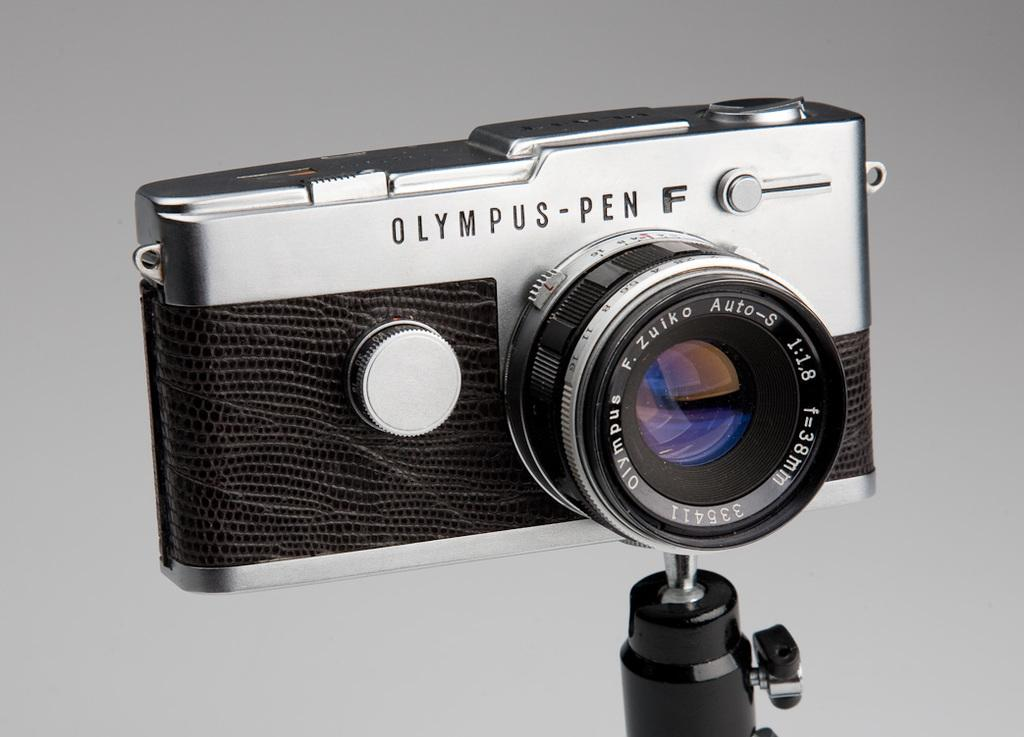What object is the main focus of the image? There is a camera in the image. Can you describe the background of the camera? The background of the camera is in grey color. How many balls are being used to prop up the camera in the image? There are no balls present in the image, and the camera is not being propped up by any objects. 